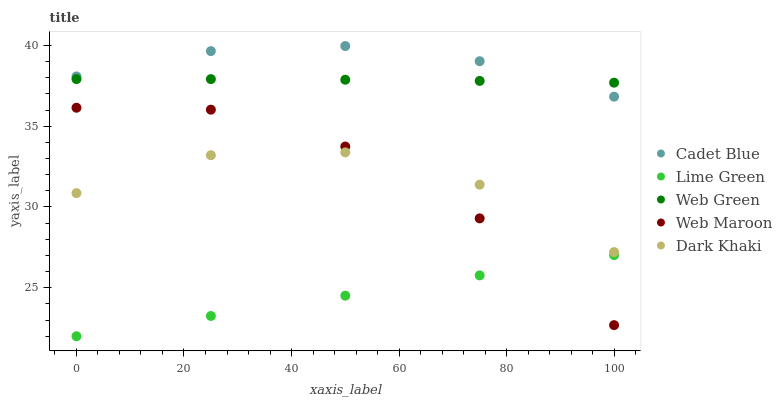Does Lime Green have the minimum area under the curve?
Answer yes or no. Yes. Does Cadet Blue have the maximum area under the curve?
Answer yes or no. Yes. Does Web Maroon have the minimum area under the curve?
Answer yes or no. No. Does Web Maroon have the maximum area under the curve?
Answer yes or no. No. Is Lime Green the smoothest?
Answer yes or no. Yes. Is Dark Khaki the roughest?
Answer yes or no. Yes. Is Web Maroon the smoothest?
Answer yes or no. No. Is Web Maroon the roughest?
Answer yes or no. No. Does Lime Green have the lowest value?
Answer yes or no. Yes. Does Web Maroon have the lowest value?
Answer yes or no. No. Does Cadet Blue have the highest value?
Answer yes or no. Yes. Does Web Maroon have the highest value?
Answer yes or no. No. Is Dark Khaki less than Web Green?
Answer yes or no. Yes. Is Dark Khaki greater than Lime Green?
Answer yes or no. Yes. Does Web Green intersect Cadet Blue?
Answer yes or no. Yes. Is Web Green less than Cadet Blue?
Answer yes or no. No. Is Web Green greater than Cadet Blue?
Answer yes or no. No. Does Dark Khaki intersect Web Green?
Answer yes or no. No. 